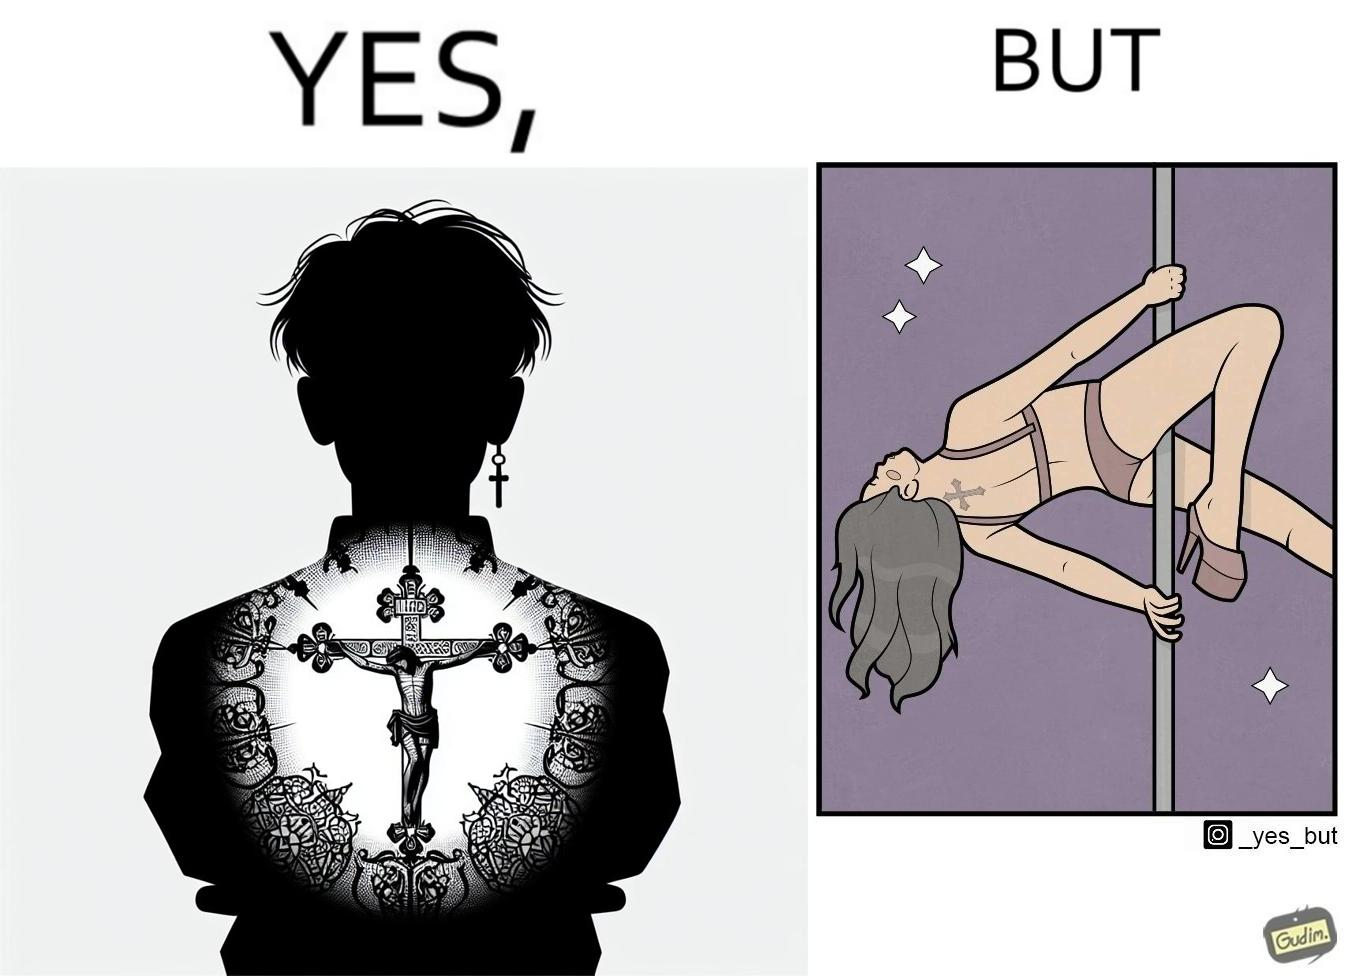What makes this image funny or satirical? This image may present two different ideas, firstly even she is such a believer in god that she has got a tatto of holy cross symbol on her back but her situations have forced her to do a job at a bar or some place performing pole dance and secondly she is using a religious symbol to glorify her look so that more people acknowledge her dance and give her some money 